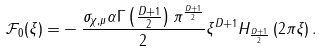Convert formula to latex. <formula><loc_0><loc_0><loc_500><loc_500>\mathcal { F } _ { 0 } ( \xi ) = & - \frac { \sigma _ { \chi , \mu } \alpha \Gamma \left ( \frac { D + 1 } { 2 } \right ) \pi ^ { \frac { D + 1 } { 2 } } } { 2 } \xi ^ { D + 1 } H _ { \frac { D + 1 } { 2 } } \left ( 2 \pi \xi \right ) .</formula> 